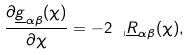<formula> <loc_0><loc_0><loc_500><loc_500>\frac { \partial \underline { g } _ { \alpha \beta } ( \chi ) } { \partial \chi } = - 2 \ _ { \shortmid } \underline { R } _ { \alpha \beta } ( \chi ) ,</formula> 